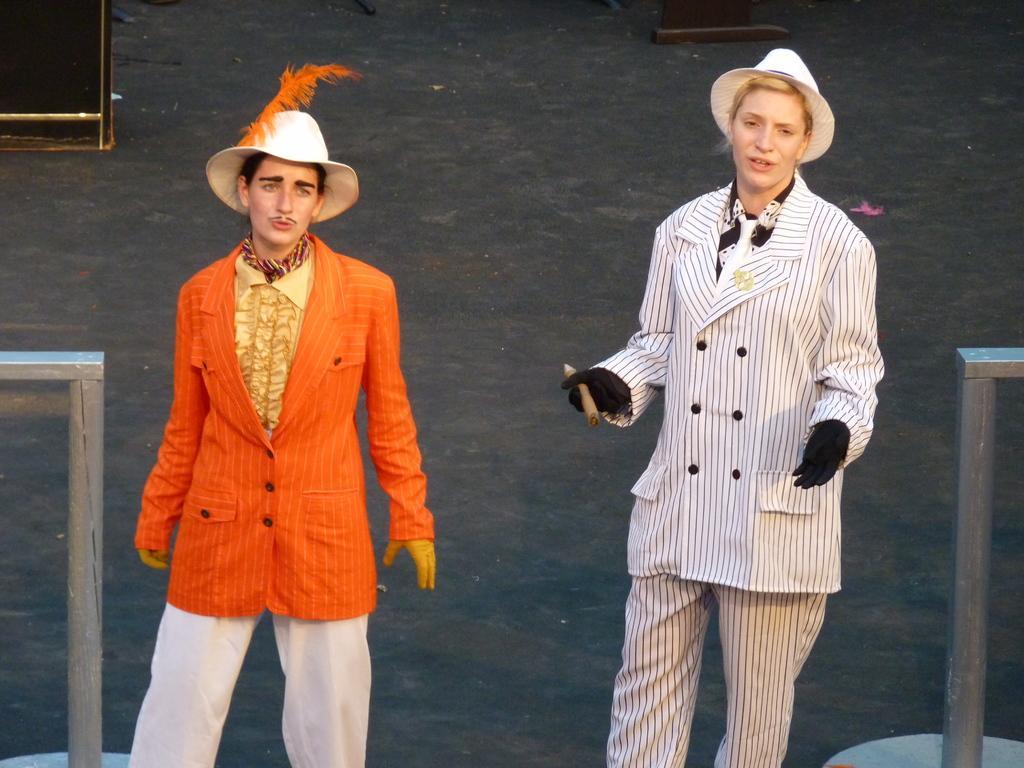Could you give a brief overview of what you see in this image? In this picture we can see two people wearing a costume. We can see two stands on the right and left side of the image. There are other objects visible in the background. 